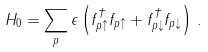Convert formula to latex. <formula><loc_0><loc_0><loc_500><loc_500>H _ { 0 } = \sum _ { p } \epsilon \left ( f ^ { \dagger } _ { p \uparrow } f _ { p \uparrow } + f ^ { \dagger } _ { p \downarrow } f _ { p \downarrow } \right ) \, .</formula> 